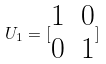Convert formula to latex. <formula><loc_0><loc_0><loc_500><loc_500>U _ { 1 } = [ \begin{matrix} 1 & 0 \\ 0 & 1 \end{matrix} ]</formula> 